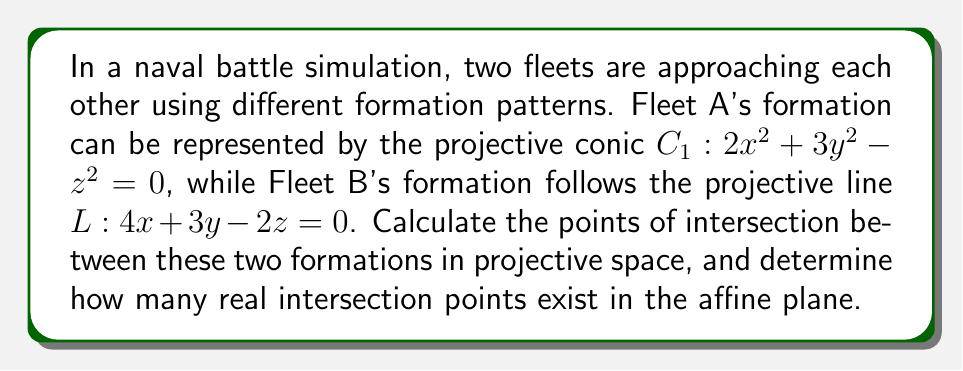Show me your answer to this math problem. To solve this problem, we'll follow these steps:

1) First, we need to find the intersection points of the conic $C_1$ and the line $L$ in projective space.

2) To do this, we'll substitute the equation of the line into the equation of the conic.

3) From the line equation, we can express $z$ in terms of $x$ and $y$:
   $z = 2x + \frac{3}{2}y$

4) Substituting this into the conic equation:
   $2x^2 + 3y^2 - (2x + \frac{3}{2}y)^2 = 0$

5) Expanding:
   $2x^2 + 3y^2 - (4x^2 + 6xy + \frac{9}{4}y^2) = 0$

6) Simplifying:
   $-2x^2 - 6xy + \frac{3}{4}y^2 = 0$

7) Multiplying by 4 to eliminate fractions:
   $-8x^2 - 24xy + 3y^2 = 0$

8) This is a quadratic in $x$. We can solve it using the quadratic formula:
   $x = \frac{-b \pm \sqrt{b^2 - 4ac}}{2a}$

   where $a = -8$, $b = -24y$, and $c = 3y^2$

9) Substituting:
   $x = \frac{24y \pm \sqrt{576y^2 - 96y^2}}{-16}$
      $= \frac{24y \pm \sqrt{480y^2}}{-16}$
      $= \frac{24y \pm 4y\sqrt{30}}{-16}$
      $= \frac{-3y \pm y\sqrt{30}}{2}$

10) To find $z$, we substitute this $x$ back into the line equation:
    $z = 2(\frac{-3y \pm y\sqrt{30}}{2}) + \frac{3}{2}y = -3y \pm y\sqrt{30} + \frac{3}{2}y = \frac{-3y \pm 2y\sqrt{30}}{2}$

11) Therefore, the two intersection points in projective space are:
    $P_1 = (\frac{-3y + y\sqrt{30}}{2} : y : \frac{-3y + 2y\sqrt{30}}{2})$
    $P_2 = (\frac{-3y - y\sqrt{30}}{2} : y : \frac{-3y - 2y\sqrt{30}}{2})$

12) To determine how many real intersection points exist in the affine plane, we need to check if $y$ can be zero:
    If $y = 0$, then $x = 0$ and $z = 0$, which is not a valid point in projective space.
    Therefore, we can divide all coordinates by $y$ to get the affine points:
    $P_1 = (\frac{-3 + \sqrt{30}}{2}, 1, \frac{-3 + 2\sqrt{30}}{2})$
    $P_2 = (\frac{-3 - \sqrt{30}}{2}, 1, \frac{-3 - 2\sqrt{30}}{2})$

Both of these points are real, so there are two real intersection points in the affine plane.
Answer: Two real intersection points: $(\frac{-3 + \sqrt{30}}{2}, 1, \frac{-3 + 2\sqrt{30}}{2})$ and $(\frac{-3 - \sqrt{30}}{2}, 1, \frac{-3 - 2\sqrt{30}}{2})$ 